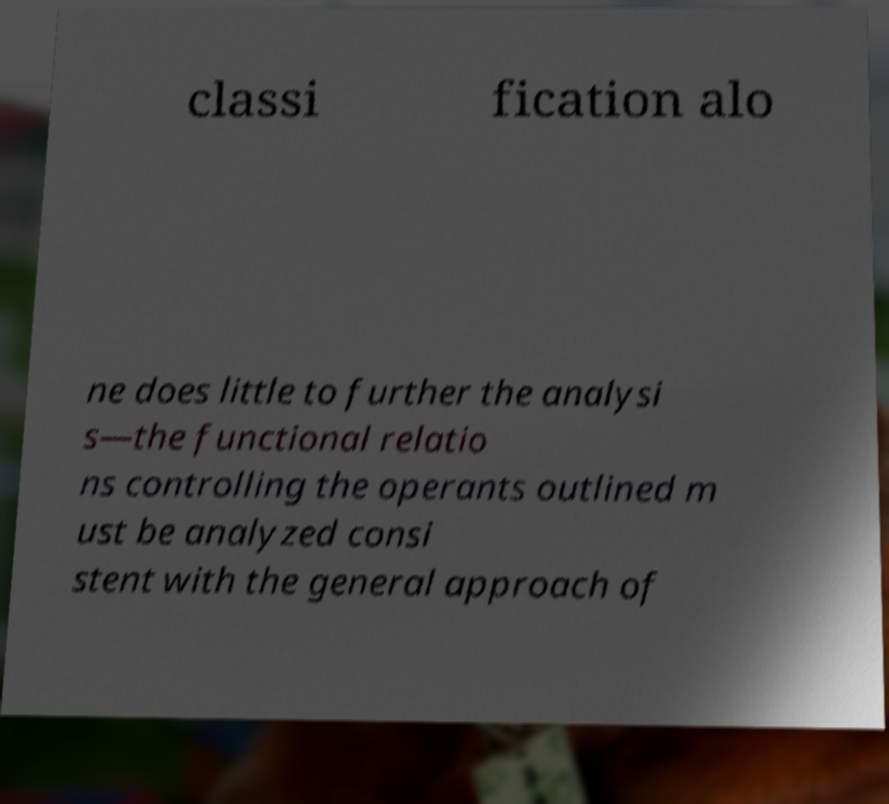Could you extract and type out the text from this image? classi fication alo ne does little to further the analysi s—the functional relatio ns controlling the operants outlined m ust be analyzed consi stent with the general approach of 